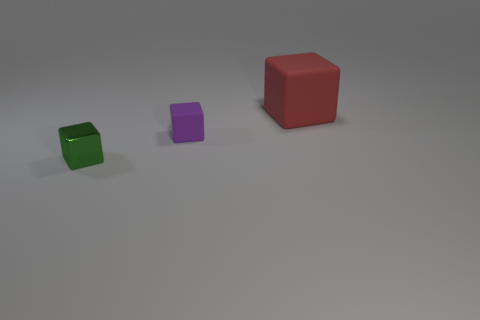Is there anything else that is the same material as the green object?
Ensure brevity in your answer.  No. There is a small green thing that is the same shape as the big rubber object; what is its material?
Ensure brevity in your answer.  Metal. What material is the cube behind the purple matte cube?
Offer a very short reply. Rubber. What color is the tiny object that is made of the same material as the red block?
Keep it short and to the point. Purple. How many green cubes are the same size as the purple matte object?
Provide a short and direct response. 1. Do the block that is in front of the purple matte cube and the red rubber block have the same size?
Provide a succinct answer. No. Are there any purple things right of the large red thing?
Your response must be concise. No. Is there any other thing that has the same shape as the big red matte thing?
Make the answer very short. Yes. Is the big matte object the same shape as the small metallic thing?
Make the answer very short. Yes. Is the number of tiny purple blocks that are left of the small purple rubber thing the same as the number of objects that are on the right side of the big red rubber cube?
Provide a succinct answer. Yes. 